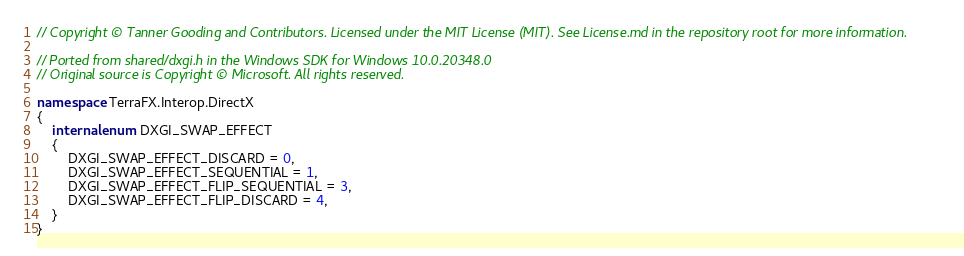Convert code to text. <code><loc_0><loc_0><loc_500><loc_500><_C#_>// Copyright © Tanner Gooding and Contributors. Licensed under the MIT License (MIT). See License.md in the repository root for more information.

// Ported from shared/dxgi.h in the Windows SDK for Windows 10.0.20348.0
// Original source is Copyright © Microsoft. All rights reserved.

namespace TerraFX.Interop.DirectX
{
    internal enum DXGI_SWAP_EFFECT
    {
        DXGI_SWAP_EFFECT_DISCARD = 0,
        DXGI_SWAP_EFFECT_SEQUENTIAL = 1,
        DXGI_SWAP_EFFECT_FLIP_SEQUENTIAL = 3,
        DXGI_SWAP_EFFECT_FLIP_DISCARD = 4,
    }
}
</code> 